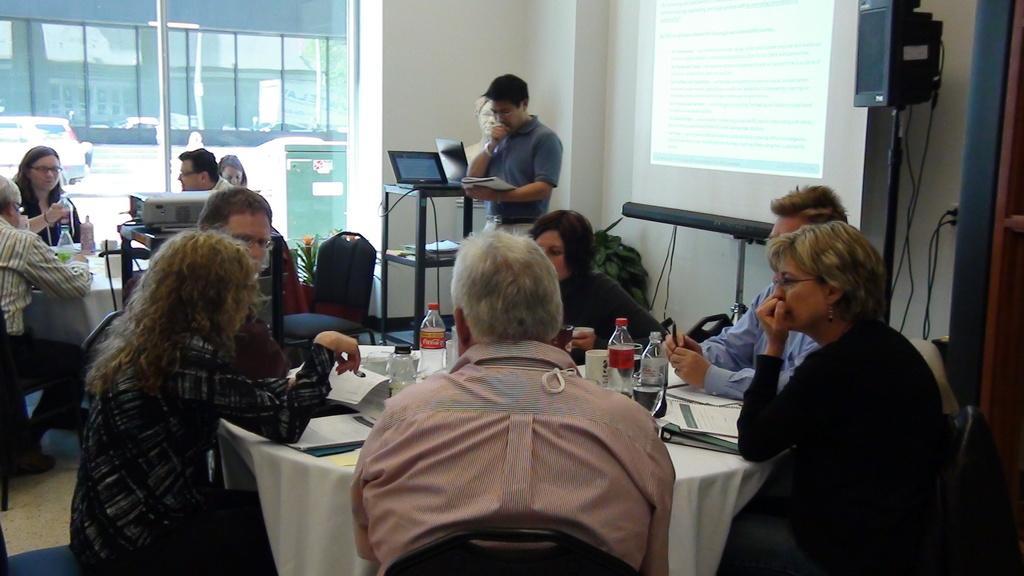Could you give a brief overview of what you see in this image? In the picture I can see a few persons sitting on the chairs and they are discussing. I can see the tables on the floor and they are covered with white cloth. I can see the books and water bottles are kept on the table. I can see the screen and a speaker on the top right side. There is a man standing on the floor and he is holding a book. I can see a laptop on the metal table. I can see the glass window on the top left side. There is a vehicle on the top left side. 